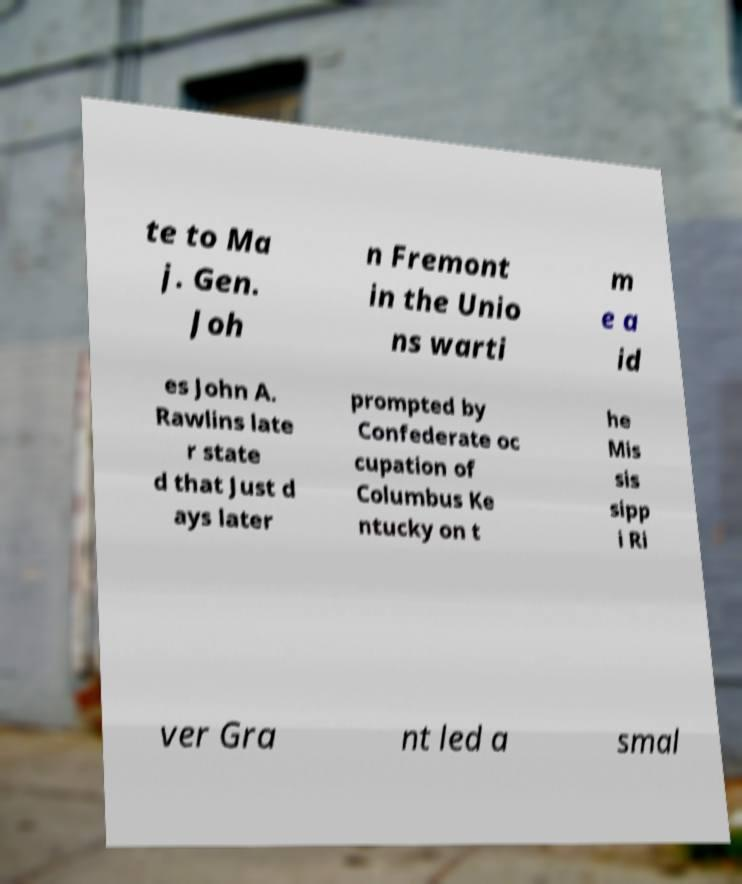Please read and relay the text visible in this image. What does it say? te to Ma j. Gen. Joh n Fremont in the Unio ns warti m e a id es John A. Rawlins late r state d that Just d ays later prompted by Confederate oc cupation of Columbus Ke ntucky on t he Mis sis sipp i Ri ver Gra nt led a smal 